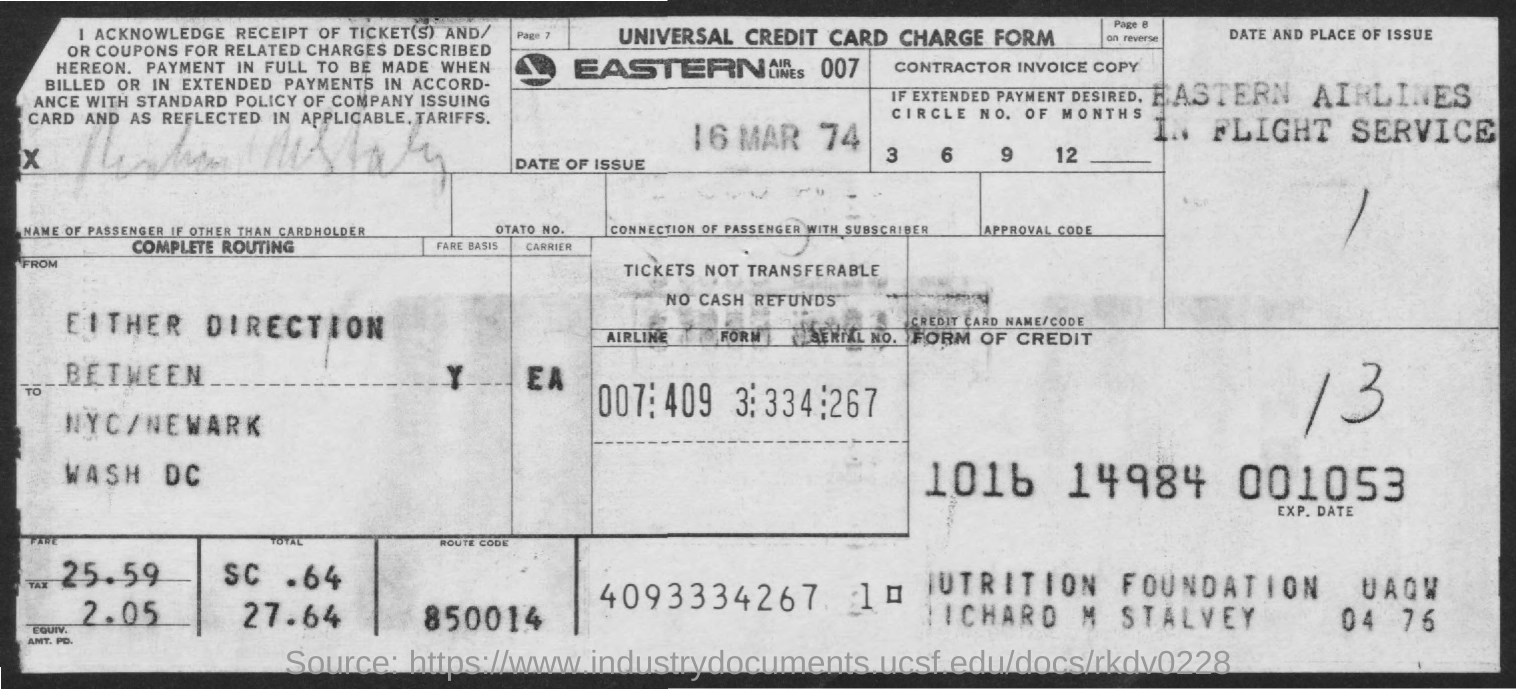Indicate a few pertinent items in this graphic. The date of issue is March 16th, 1974. I'm sorry, but I'm not sure what you mean by "route code." Could you please provide more context or clarify your question? The amount of tax is 2.05. The fare amount is 25.59. 